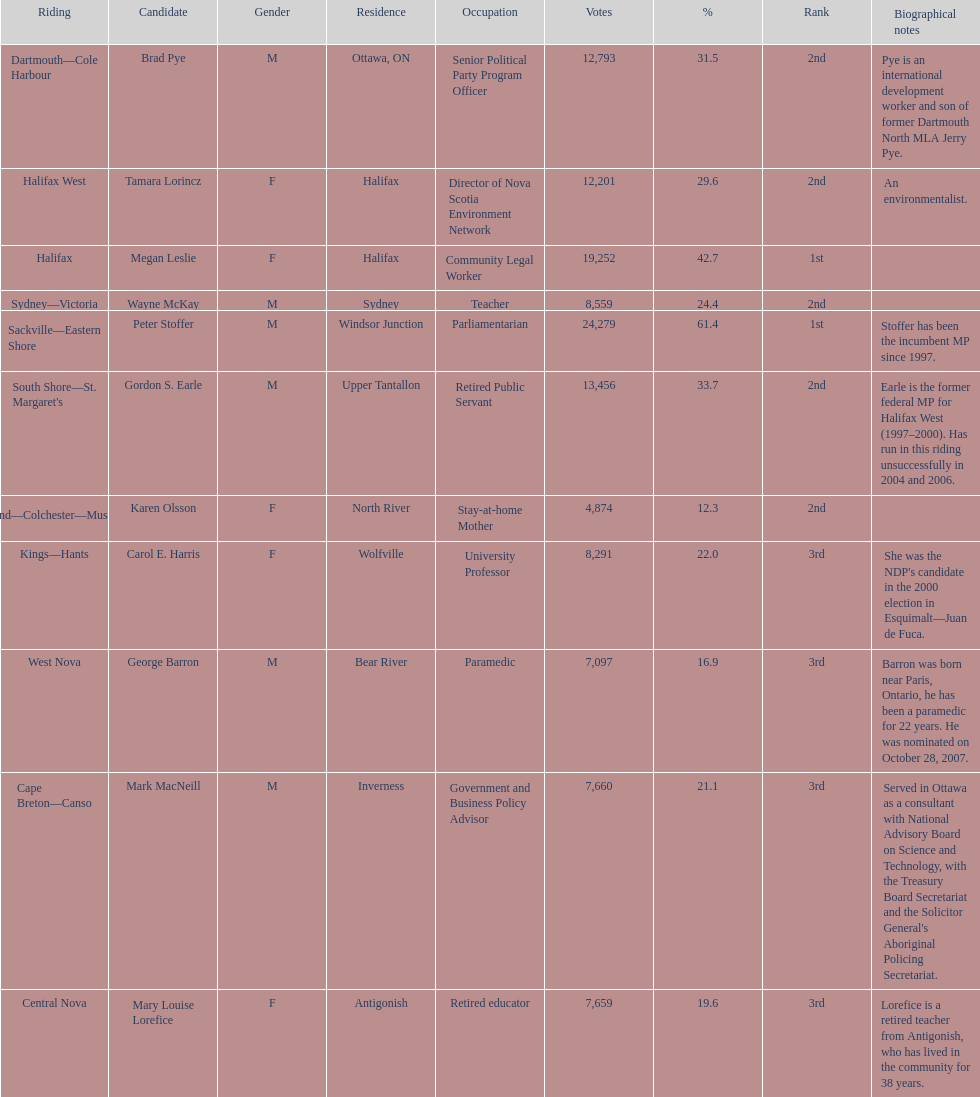Tell me the total number of votes the female candidates got. 52,277. 